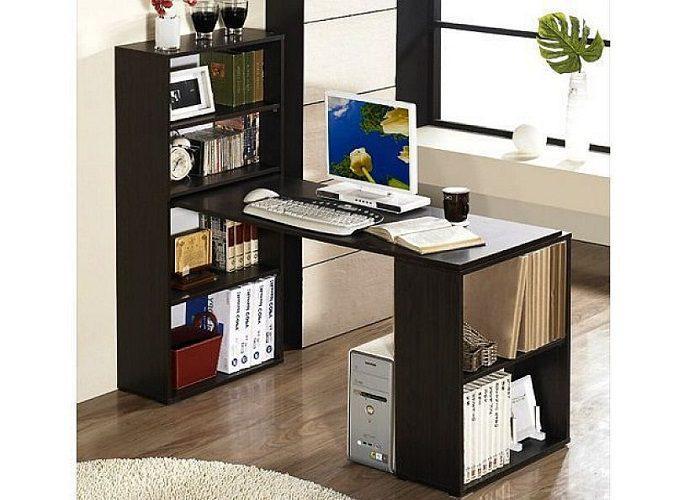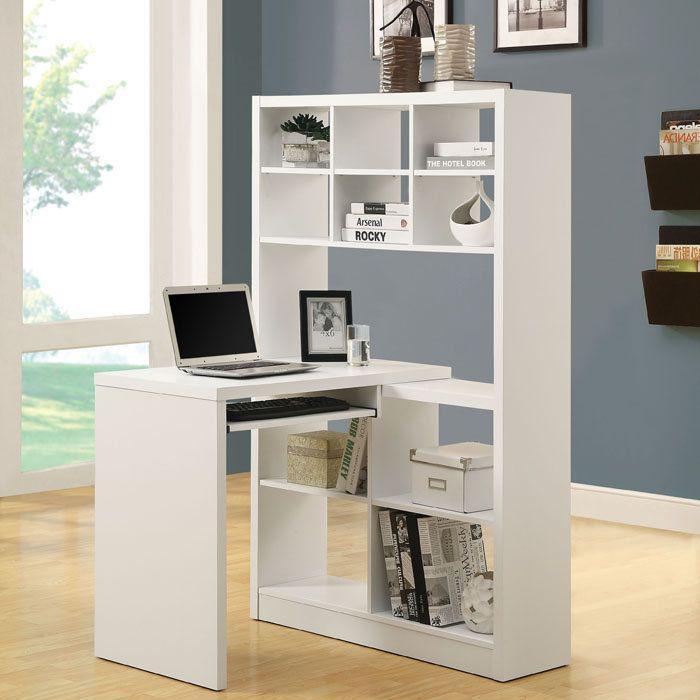The first image is the image on the left, the second image is the image on the right. For the images shown, is this caption "There is a chair on wheels next to a desk." true? Answer yes or no. No. The first image is the image on the left, the second image is the image on the right. Examine the images to the left and right. Is the description "There is a chair pulled up to at least one of the desks." accurate? Answer yes or no. No. 